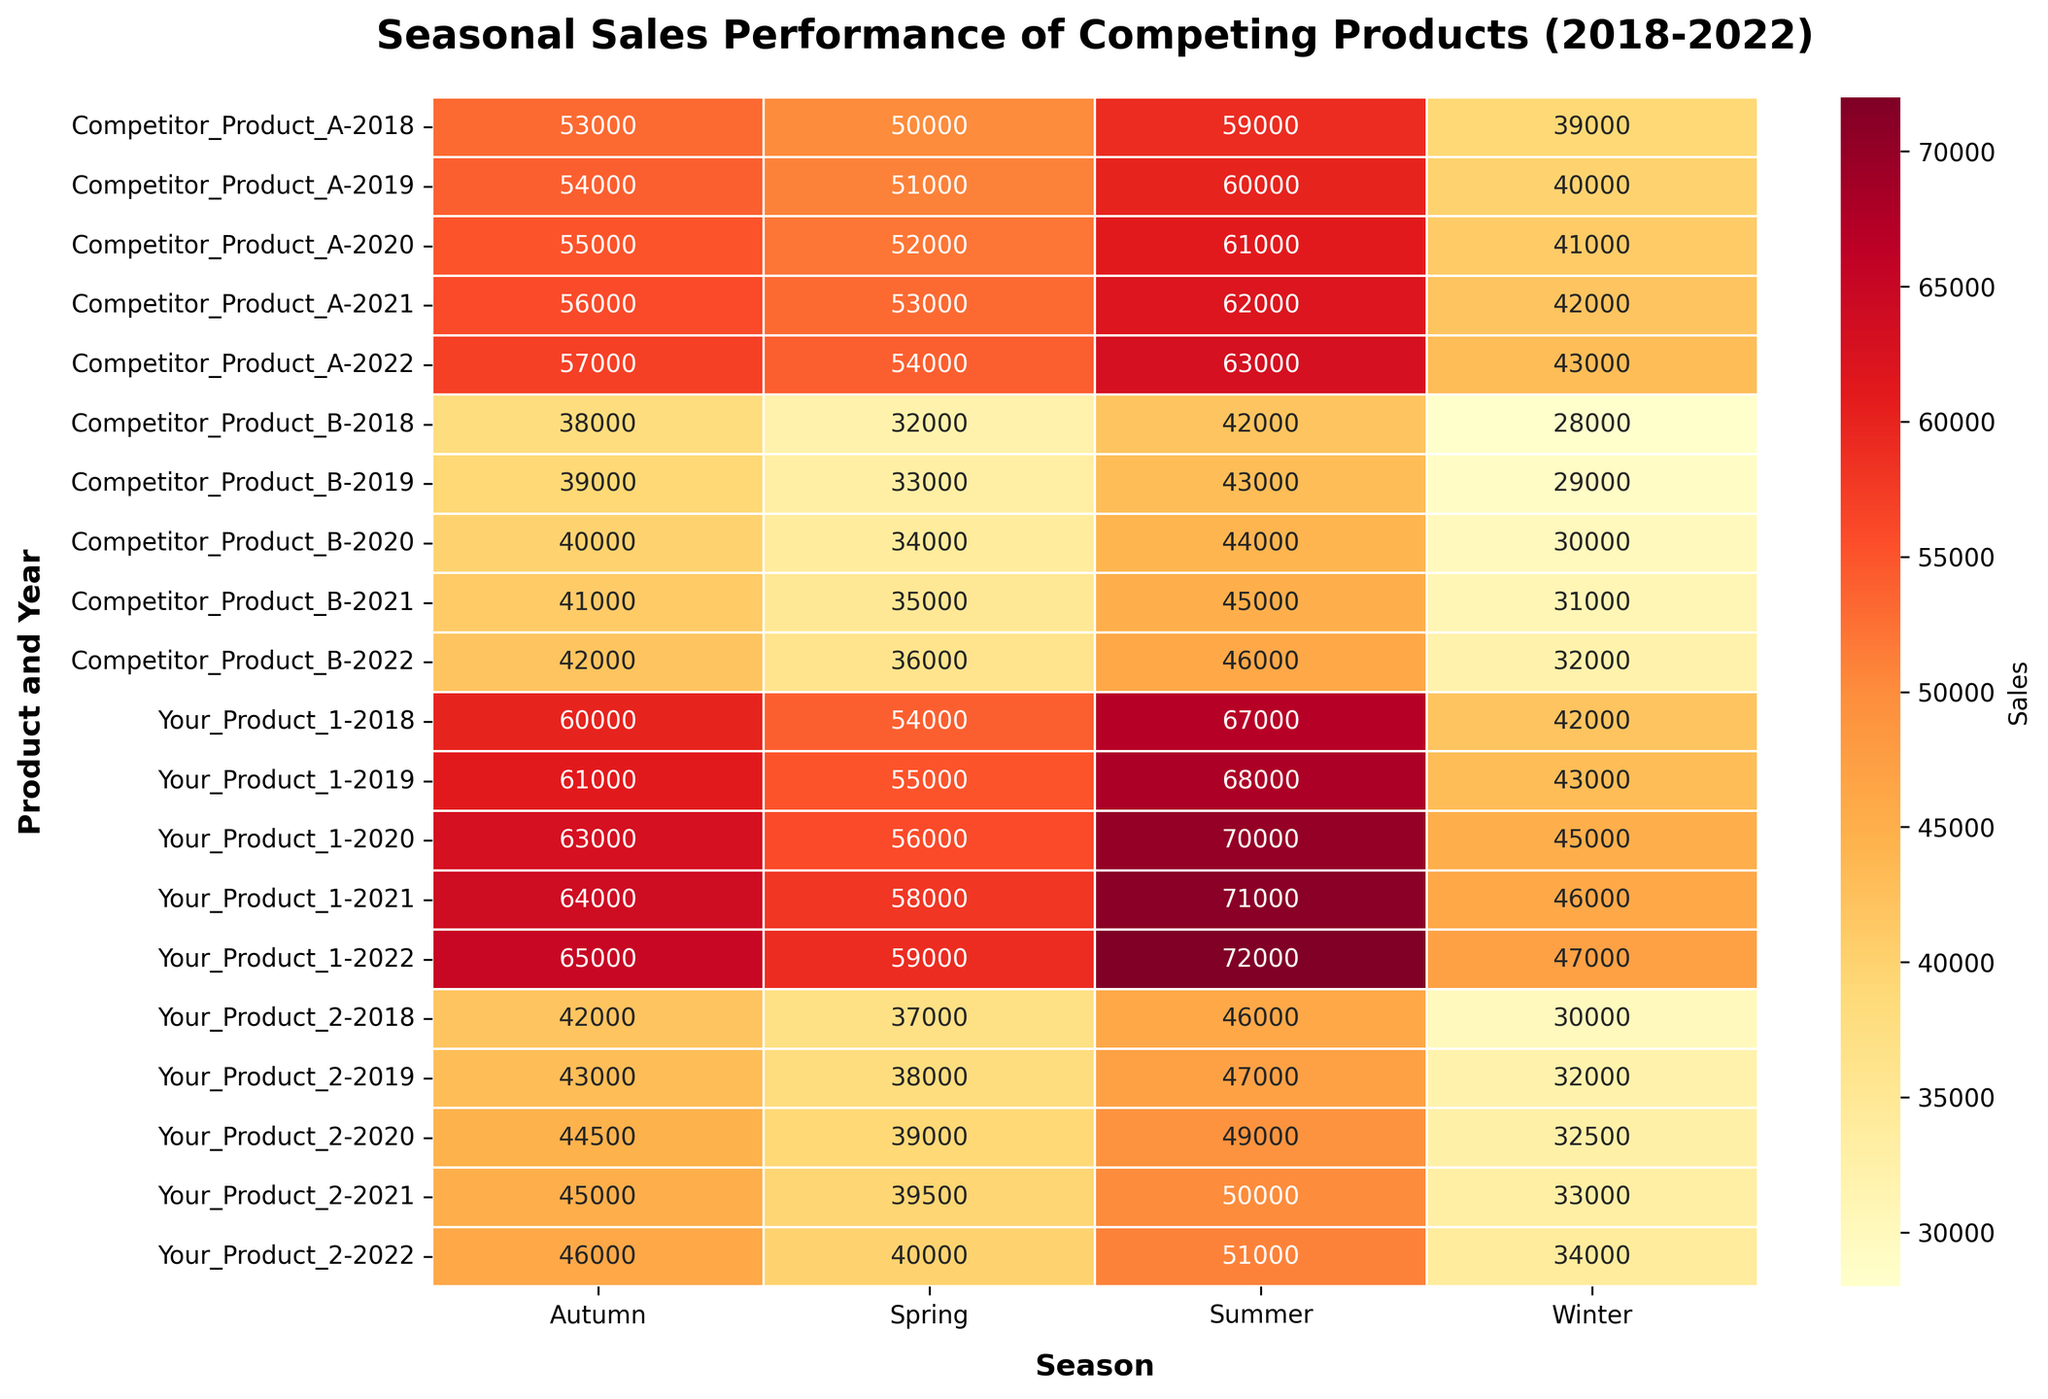What does the title of the heatmap indicate? The title "Seasonal Sales Performance of Competing Products (2018-2022)" suggests that the heatmap displays the seasonal sales data for different products from 2018 to 2022.
Answer: Seasonal sales data for different products from 2018 to 2022 Which season did "Your_Product_1" have its highest sales? By looking at the cells for "Your_Product_1," the highest sales value can be found in the summer season across all years, with 72,000 in summer 2022 being the highest.
Answer: Summer 2022 For "Competitor_Product_B," which year and season combination had the lowest sales, and what was the value? Observing "Competitor_Product_B," the lowest sales, 28,000, occurred in Winter 2018.
Answer: Winter 2018, 28,000 How did the sales of "Your_Product_2" change from Winter 2018 to Winter 2022? To find the change, subtract the Winter 2018 sales (30,000) from the Winter 2022 sales (34,000). 34,000 - 30,000 = 4,000, which shows an increase.
Answer: Increased by 4,000 Between "Your_Product_1" and "Competitor_Product_A," who had higher sales in Spring 2020, and what were the respective values? Comparing both in Spring 2020, "Your_Product_1" had sales of 56,000 while "Competitor_Product_A" had 52,000. Thus, "Your_Product_1" had higher sales.
Answer: Your_Product_1 had 56,000, Competitor_Product_A had 52,000 Which product displayed the most consistent performance across seasons and years in terms of sales? "Competitor_Product_A" shows the least variation in the sales values across different seasons and years by closely observing the heatmap, which indicates higher consistency.
Answer: Competitor_Product_A How does the average sales in Summer for "Your_Product_1" compare from 2018 to 2022? Calculate the average for each year and compare. Summer sales for "Your_Product_1": 67,000 (2018), 68,000 (2019), 70,000 (2020), 71,000 (2021), and 72,000 (2022). The sales steadily increase each year.
Answer: Steadily increased Did any product outperform "Your_Product_1" in Autumn sales in any year? If so, which, when, and what were the values? Comparing "Your_Product_1"'s Autumn sales for each year to other products, "Competitor_Product_A" had higher sales in Autumn 2022 with 57,000, compared to "Your_Product_1"'s 65,000.
Answer: No, "Your_Product_1" was always higher What trend can you observe for "Your_Product_2" sales in Spring over five years? Examining the Spring sales values for "Your_Product_2": 37,000 (2018), 38,000 (2019), 39,000 (2020), 39,500 (2021), and 40,000 (2022), there is a generally increasing trend.
Answer: Increasing trend 